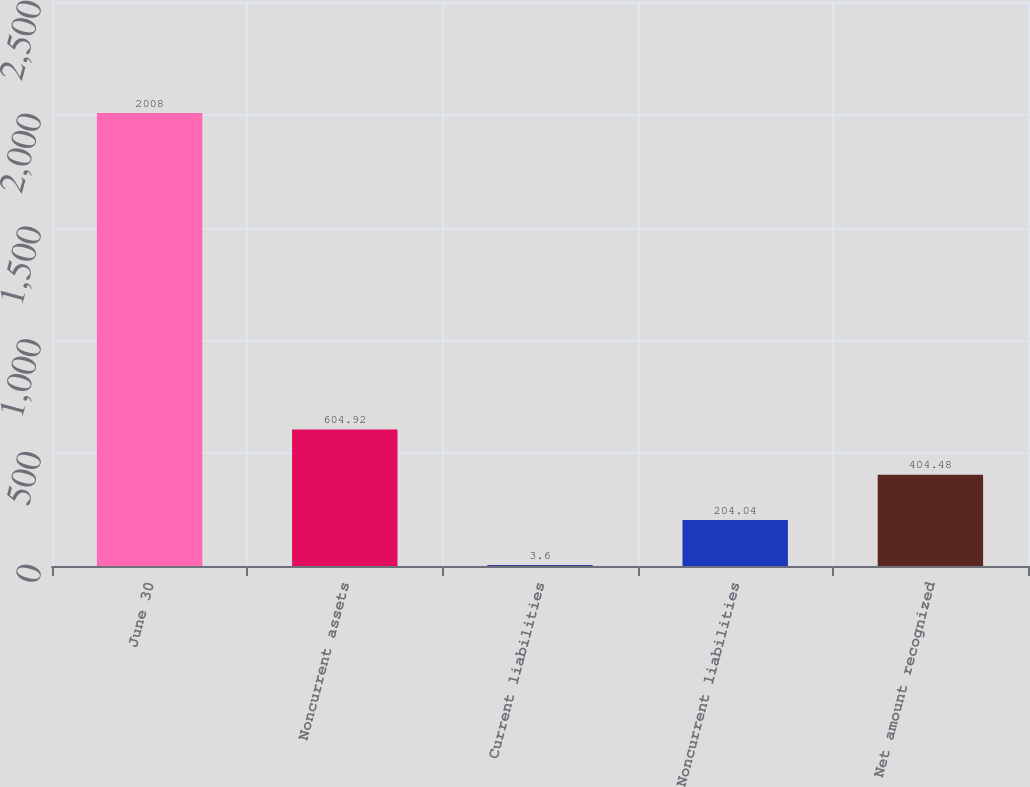Convert chart to OTSL. <chart><loc_0><loc_0><loc_500><loc_500><bar_chart><fcel>June 30<fcel>Noncurrent assets<fcel>Current liabilities<fcel>Noncurrent liabilities<fcel>Net amount recognized<nl><fcel>2008<fcel>604.92<fcel>3.6<fcel>204.04<fcel>404.48<nl></chart> 